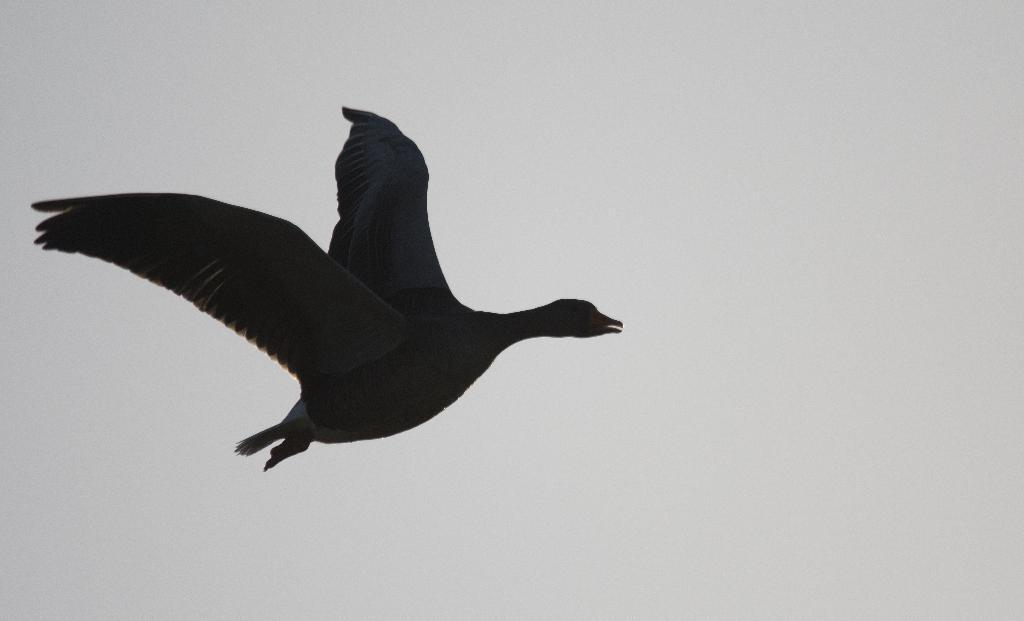What type of animal can be seen in the sky in the image? There is a bird in the sky in the image. What type of lace can be seen on the bird's wings in the image? There is no lace present on the bird's wings in the image. 